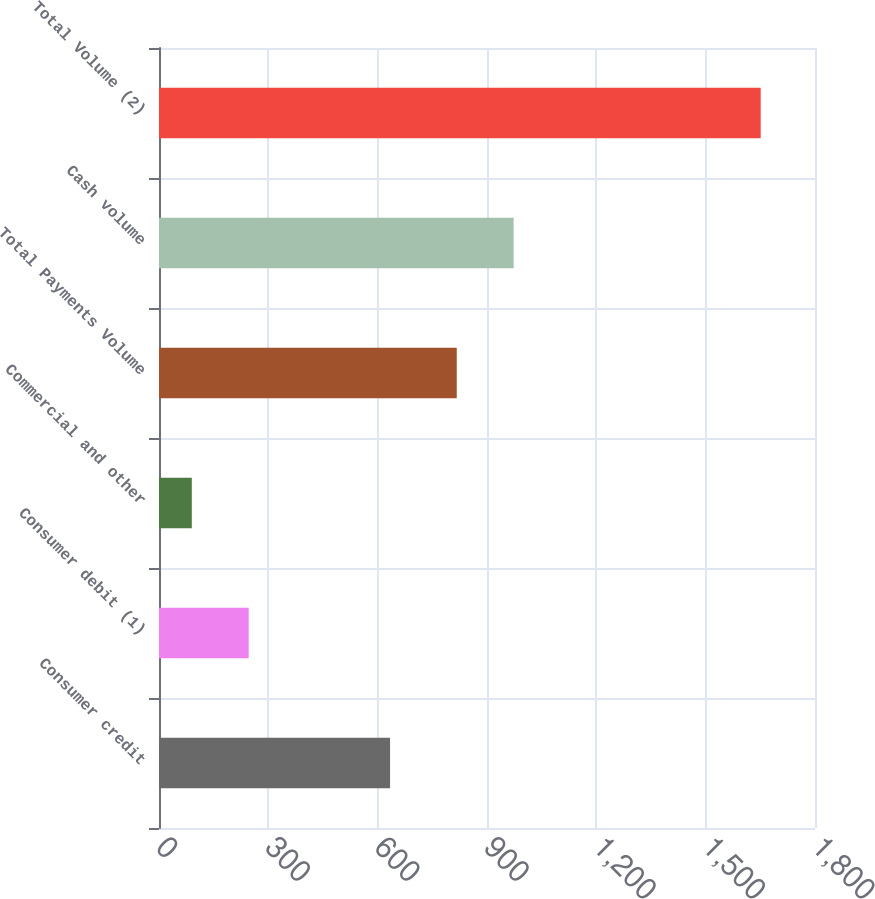Convert chart to OTSL. <chart><loc_0><loc_0><loc_500><loc_500><bar_chart><fcel>Consumer credit<fcel>Consumer debit (1)<fcel>Commercial and other<fcel>Total Payments Volume<fcel>Cash volume<fcel>Total Volume (2)<nl><fcel>634<fcel>246.1<fcel>90<fcel>817<fcel>973.1<fcel>1651<nl></chart> 